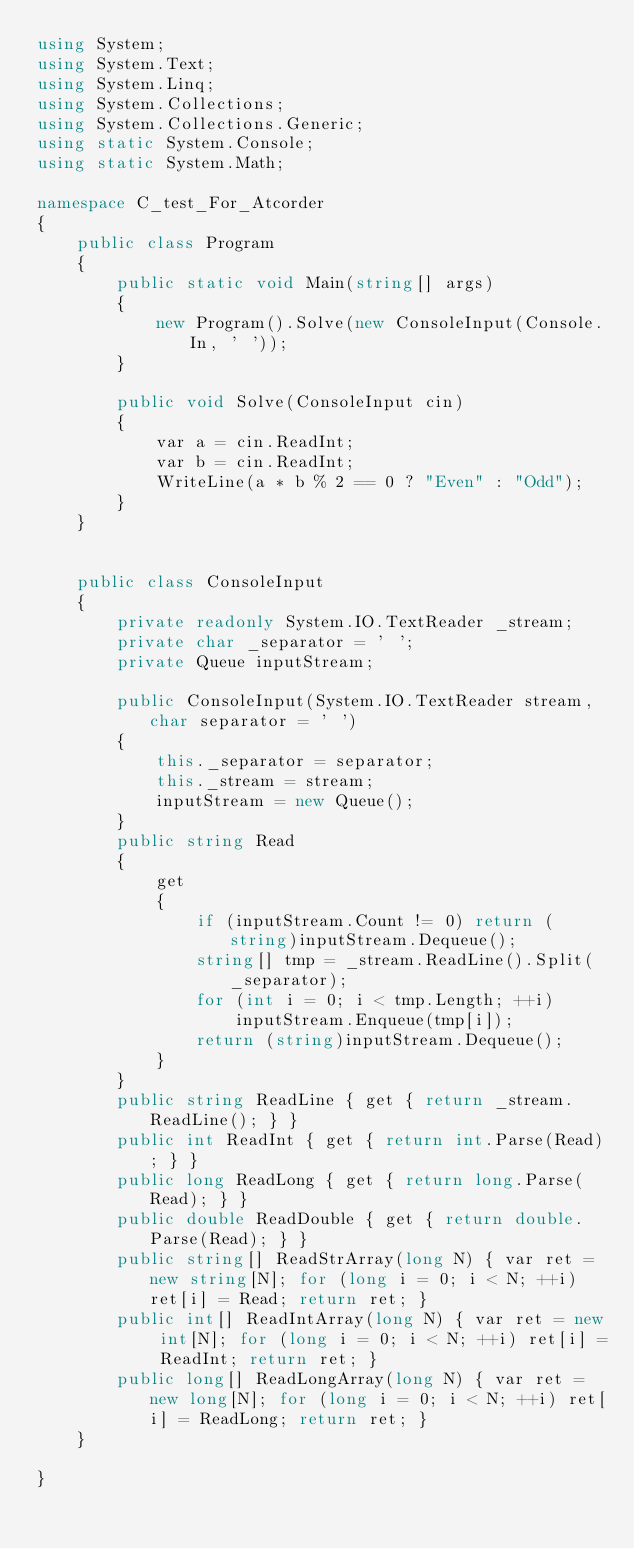Convert code to text. <code><loc_0><loc_0><loc_500><loc_500><_C#_>using System;
using System.Text;
using System.Linq;
using System.Collections;
using System.Collections.Generic;
using static System.Console;
using static System.Math;

namespace C_test_For_Atcorder
{
    public class Program
    {
        public static void Main(string[] args)
        {
            new Program().Solve(new ConsoleInput(Console.In, ' '));
        }

        public void Solve(ConsoleInput cin)
        {
            var a = cin.ReadInt;
            var b = cin.ReadInt;
            WriteLine(a * b % 2 == 0 ? "Even" : "Odd");
        }
    }


    public class ConsoleInput
    {
        private readonly System.IO.TextReader _stream;
        private char _separator = ' ';
        private Queue inputStream;

        public ConsoleInput(System.IO.TextReader stream, char separator = ' ')
        {
            this._separator = separator;
            this._stream = stream;
            inputStream = new Queue();
        }
        public string Read
        {
            get
            {
                if (inputStream.Count != 0) return (string)inputStream.Dequeue();
                string[] tmp = _stream.ReadLine().Split(_separator);
                for (int i = 0; i < tmp.Length; ++i)
                    inputStream.Enqueue(tmp[i]);
                return (string)inputStream.Dequeue();
            }
        }
        public string ReadLine { get { return _stream.ReadLine(); } }
        public int ReadInt { get { return int.Parse(Read); } }
        public long ReadLong { get { return long.Parse(Read); } }
        public double ReadDouble { get { return double.Parse(Read); } }
        public string[] ReadStrArray(long N) { var ret = new string[N]; for (long i = 0; i < N; ++i) ret[i] = Read; return ret; }
        public int[] ReadIntArray(long N) { var ret = new int[N]; for (long i = 0; i < N; ++i) ret[i] = ReadInt; return ret; }
        public long[] ReadLongArray(long N) { var ret = new long[N]; for (long i = 0; i < N; ++i) ret[i] = ReadLong; return ret; }
    }

}</code> 